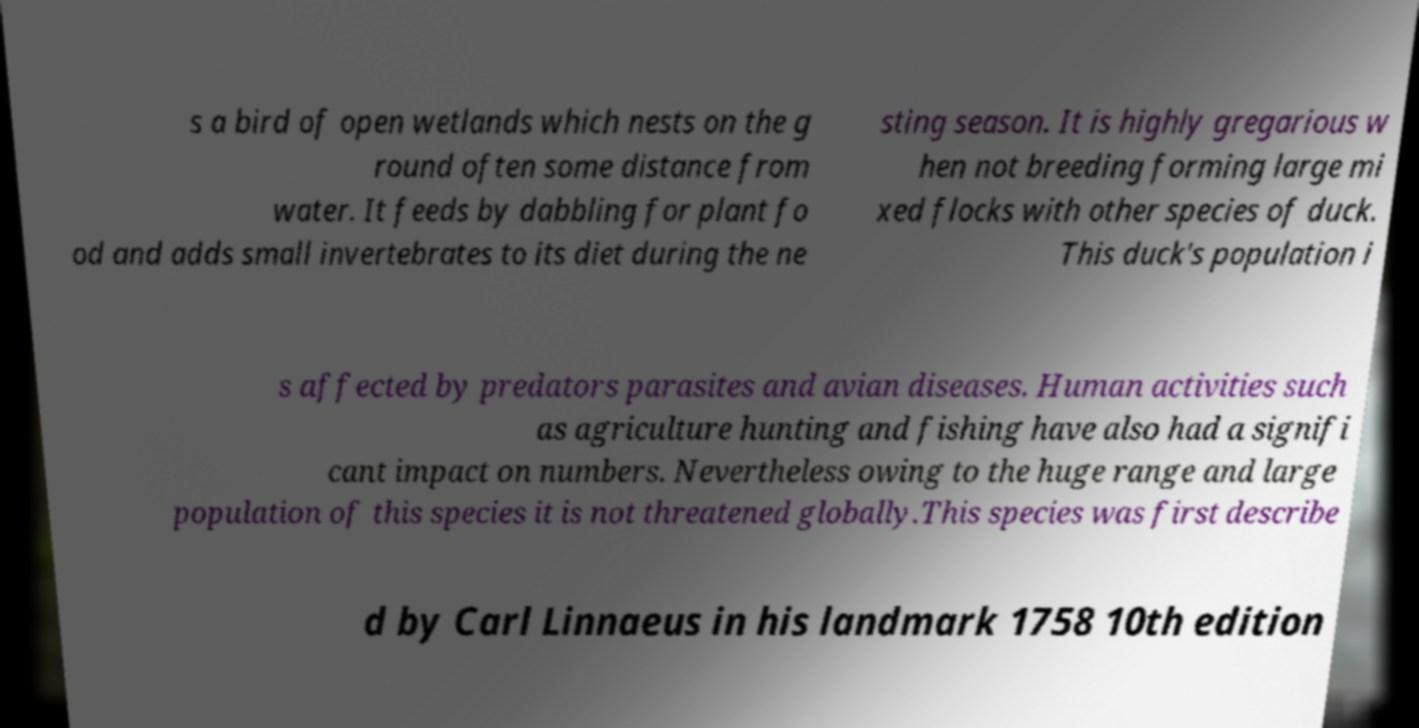Can you accurately transcribe the text from the provided image for me? s a bird of open wetlands which nests on the g round often some distance from water. It feeds by dabbling for plant fo od and adds small invertebrates to its diet during the ne sting season. It is highly gregarious w hen not breeding forming large mi xed flocks with other species of duck. This duck's population i s affected by predators parasites and avian diseases. Human activities such as agriculture hunting and fishing have also had a signifi cant impact on numbers. Nevertheless owing to the huge range and large population of this species it is not threatened globally.This species was first describe d by Carl Linnaeus in his landmark 1758 10th edition 